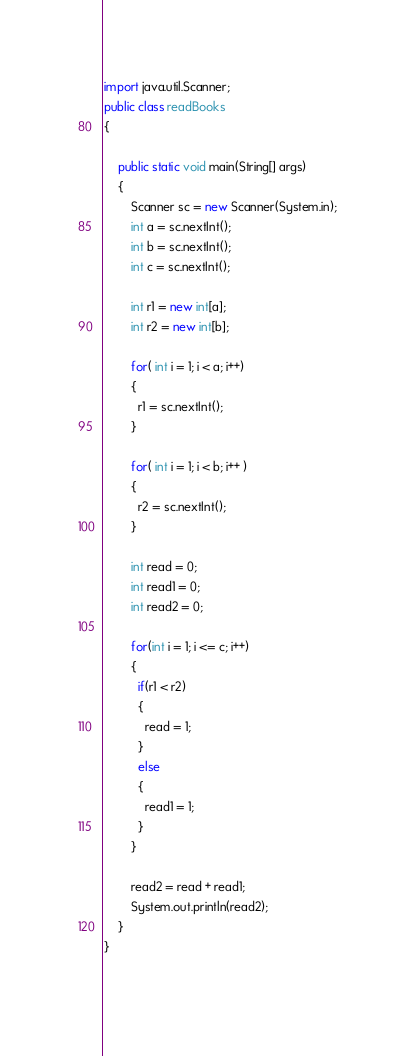Convert code to text. <code><loc_0><loc_0><loc_500><loc_500><_Java_>import java.util.Scanner;
public class readBooks
{

	public static void main(String[] args)
	{
		Scanner sc = new Scanner(System.in);
		int a = sc.nextInt();
		int b = sc.nextInt();
        int c = sc.nextInt();
      
        int r1 = new int[a];
        int r2 = new int[b];
      
        for( int i = 1; i < a; i++)
        {
          r1 = sc.nextInt();
        }
       
        for( int i = 1; i < b; i++ )
        {
          r2 = sc.nextInt();
        }
      
        int read = 0;
        int read1 = 0;
        int read2 = 0;
      
        for(int i = 1; i <= c; i++)
        {
          if(r1 < r2)
          {
            read = 1;
          }
          else
          {
            read1 = 1;
          }
        }
      
       	read2 = read + read1;
      	System.out.println(read2);
    }
}
      </code> 